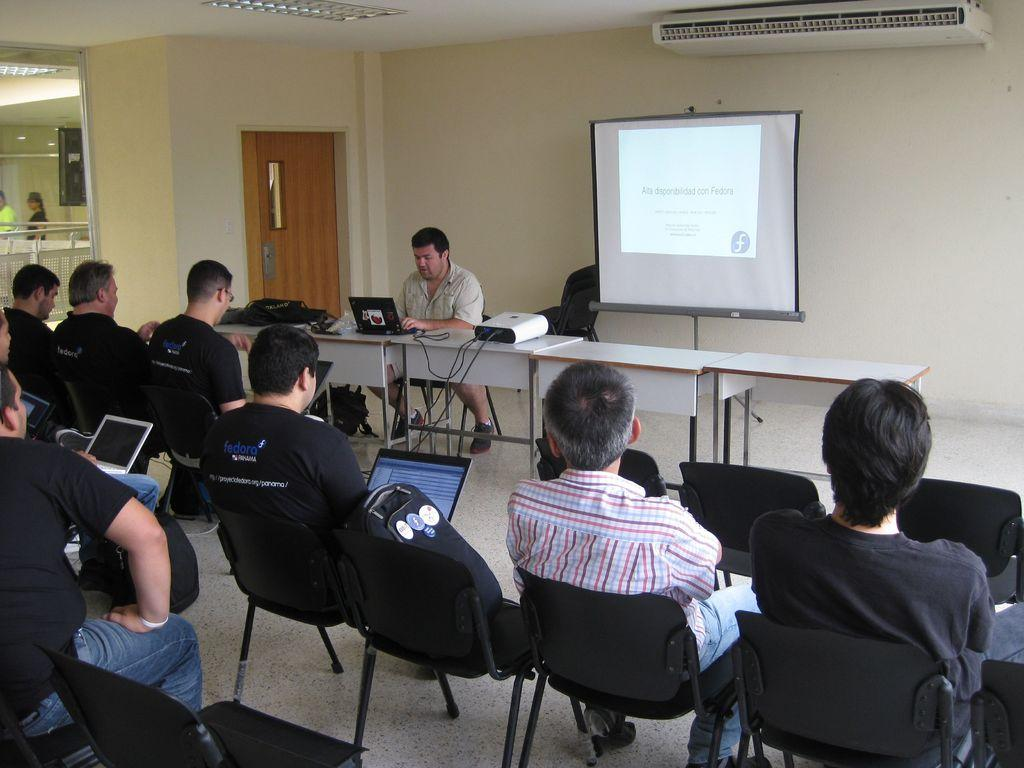What are the people in the image doing? The people in the image are sitting on chairs at the bottom of the image. What objects can be seen in the image besides the people? There are tables in the image. What is the main feature in the center of the image? There is a screen in the center of the image. What can be seen in the background of the image? There is a wall and a door in the background of the image. What type of joke is being told by the goose in the image? There is no goose present in the image, and therefore no joke can be observed. Is there a band playing in the background of the image? There is no band present in the image; the background features a wall and a door. 